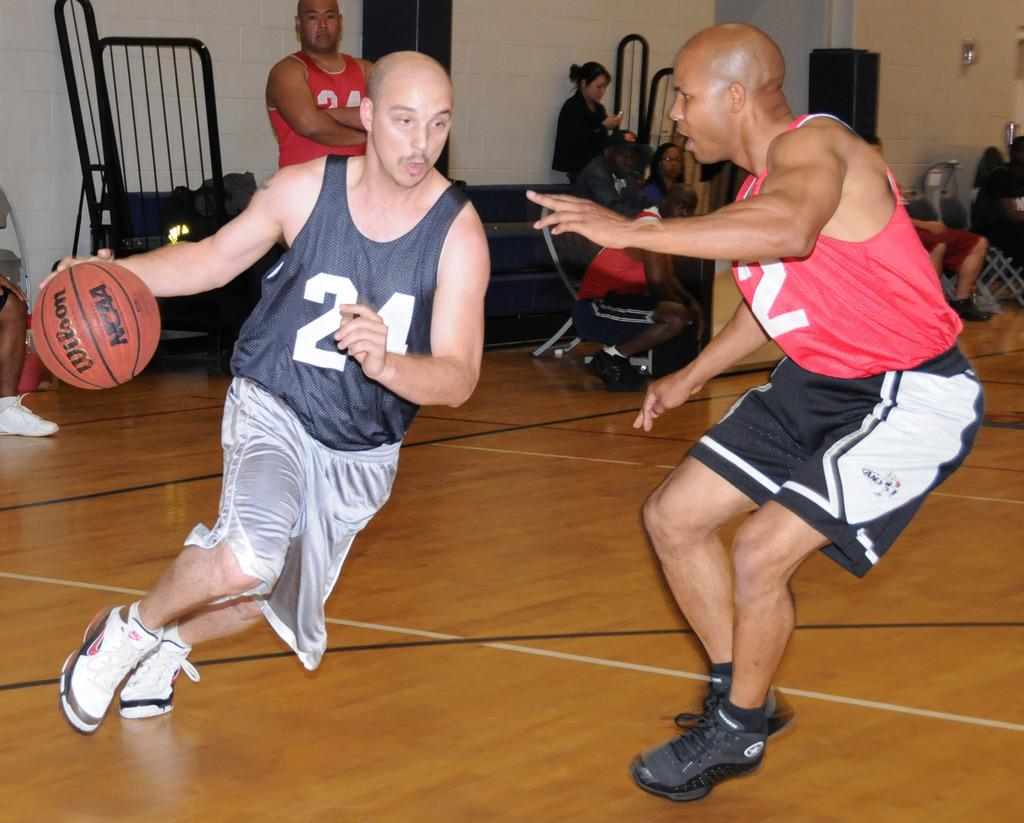<image>
Create a compact narrative representing the image presented. Two people playing basketball, one with 24 on his shirt. 